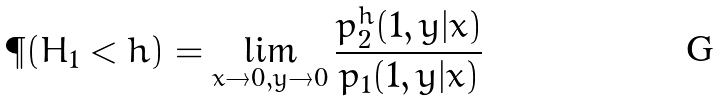<formula> <loc_0><loc_0><loc_500><loc_500>\P ( H _ { 1 } < h ) = \lim _ { x \to 0 , y \to 0 } \frac { p _ { 2 } ^ { h } ( 1 , y | x ) } { p _ { 1 } ( 1 , y | x ) }</formula> 